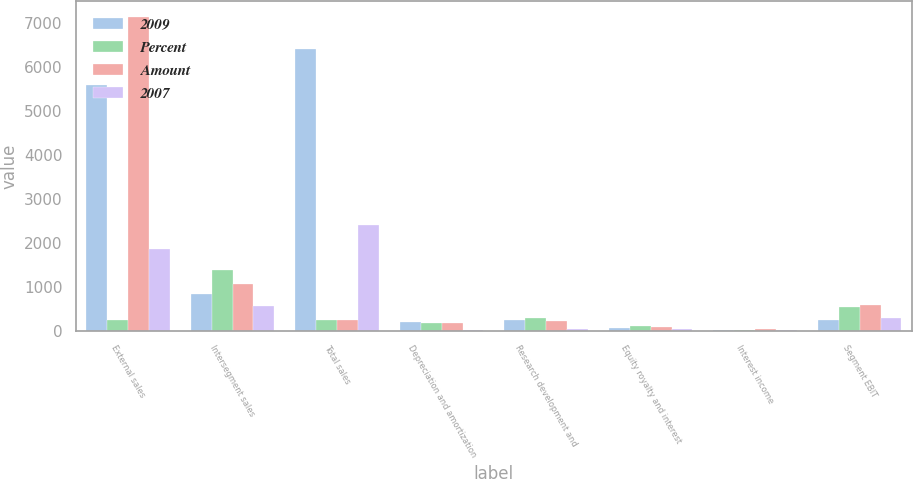Convert chart. <chart><loc_0><loc_0><loc_500><loc_500><stacked_bar_chart><ecel><fcel>External sales<fcel>Intersegment sales<fcel>Total sales<fcel>Depreciation and amortization<fcel>Research development and<fcel>Equity royalty and interest<fcel>Interest income<fcel>Segment EBIT<nl><fcel>2009<fcel>5582<fcel>823<fcel>6405<fcel>185<fcel>241<fcel>54<fcel>3<fcel>252<nl><fcel>Percent<fcel>241<fcel>1378<fcel>241<fcel>180<fcel>286<fcel>99<fcel>10<fcel>535<nl><fcel>Amount<fcel>7129<fcel>1053<fcel>241<fcel>176<fcel>222<fcel>92<fcel>26<fcel>589<nl><fcel>2007<fcel>1850<fcel>555<fcel>2405<fcel>5<fcel>45<fcel>45<fcel>7<fcel>283<nl></chart> 